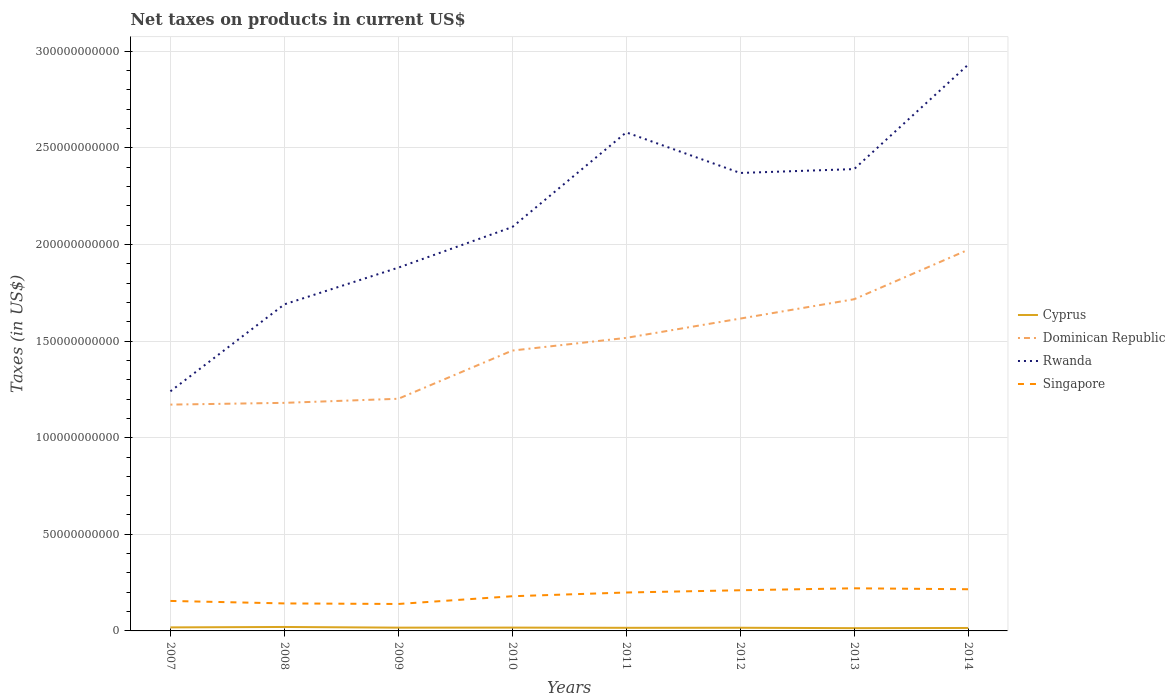Is the number of lines equal to the number of legend labels?
Keep it short and to the point. Yes. Across all years, what is the maximum net taxes on products in Singapore?
Your answer should be compact. 1.39e+1. What is the total net taxes on products in Dominican Republic in the graph?
Your response must be concise. -6.57e+09. What is the difference between the highest and the second highest net taxes on products in Cyprus?
Offer a very short reply. 6.08e+08. What is the difference between the highest and the lowest net taxes on products in Rwanda?
Provide a short and direct response. 4. How many years are there in the graph?
Provide a short and direct response. 8. Are the values on the major ticks of Y-axis written in scientific E-notation?
Offer a terse response. No. Does the graph contain grids?
Make the answer very short. Yes. How many legend labels are there?
Your answer should be compact. 4. How are the legend labels stacked?
Ensure brevity in your answer.  Vertical. What is the title of the graph?
Your response must be concise. Net taxes on products in current US$. Does "Micronesia" appear as one of the legend labels in the graph?
Provide a short and direct response. No. What is the label or title of the Y-axis?
Make the answer very short. Taxes (in US$). What is the Taxes (in US$) in Cyprus in 2007?
Your answer should be very brief. 1.83e+09. What is the Taxes (in US$) in Dominican Republic in 2007?
Provide a short and direct response. 1.17e+11. What is the Taxes (in US$) in Rwanda in 2007?
Keep it short and to the point. 1.24e+11. What is the Taxes (in US$) in Singapore in 2007?
Your answer should be compact. 1.55e+1. What is the Taxes (in US$) of Cyprus in 2008?
Your response must be concise. 2.04e+09. What is the Taxes (in US$) in Dominican Republic in 2008?
Your answer should be very brief. 1.18e+11. What is the Taxes (in US$) of Rwanda in 2008?
Offer a terse response. 1.69e+11. What is the Taxes (in US$) of Singapore in 2008?
Give a very brief answer. 1.42e+1. What is the Taxes (in US$) of Cyprus in 2009?
Offer a very short reply. 1.70e+09. What is the Taxes (in US$) of Dominican Republic in 2009?
Your answer should be compact. 1.20e+11. What is the Taxes (in US$) in Rwanda in 2009?
Provide a succinct answer. 1.88e+11. What is the Taxes (in US$) in Singapore in 2009?
Your answer should be compact. 1.39e+1. What is the Taxes (in US$) in Cyprus in 2010?
Give a very brief answer. 1.72e+09. What is the Taxes (in US$) of Dominican Republic in 2010?
Offer a very short reply. 1.45e+11. What is the Taxes (in US$) of Rwanda in 2010?
Your response must be concise. 2.09e+11. What is the Taxes (in US$) in Singapore in 2010?
Offer a terse response. 1.80e+1. What is the Taxes (in US$) in Cyprus in 2011?
Your answer should be compact. 1.61e+09. What is the Taxes (in US$) in Dominican Republic in 2011?
Your response must be concise. 1.52e+11. What is the Taxes (in US$) of Rwanda in 2011?
Make the answer very short. 2.58e+11. What is the Taxes (in US$) in Singapore in 2011?
Your response must be concise. 1.99e+1. What is the Taxes (in US$) in Cyprus in 2012?
Provide a short and direct response. 1.64e+09. What is the Taxes (in US$) in Dominican Republic in 2012?
Provide a short and direct response. 1.62e+11. What is the Taxes (in US$) in Rwanda in 2012?
Your response must be concise. 2.37e+11. What is the Taxes (in US$) of Singapore in 2012?
Ensure brevity in your answer.  2.10e+1. What is the Taxes (in US$) of Cyprus in 2013?
Provide a short and direct response. 1.43e+09. What is the Taxes (in US$) in Dominican Republic in 2013?
Keep it short and to the point. 1.72e+11. What is the Taxes (in US$) in Rwanda in 2013?
Offer a very short reply. 2.39e+11. What is the Taxes (in US$) in Singapore in 2013?
Your answer should be compact. 2.21e+1. What is the Taxes (in US$) in Cyprus in 2014?
Provide a succinct answer. 1.53e+09. What is the Taxes (in US$) in Dominican Republic in 2014?
Ensure brevity in your answer.  1.97e+11. What is the Taxes (in US$) in Rwanda in 2014?
Provide a short and direct response. 2.93e+11. What is the Taxes (in US$) of Singapore in 2014?
Offer a very short reply. 2.16e+1. Across all years, what is the maximum Taxes (in US$) in Cyprus?
Provide a succinct answer. 2.04e+09. Across all years, what is the maximum Taxes (in US$) in Dominican Republic?
Provide a succinct answer. 1.97e+11. Across all years, what is the maximum Taxes (in US$) of Rwanda?
Provide a succinct answer. 2.93e+11. Across all years, what is the maximum Taxes (in US$) in Singapore?
Your answer should be very brief. 2.21e+1. Across all years, what is the minimum Taxes (in US$) in Cyprus?
Provide a short and direct response. 1.43e+09. Across all years, what is the minimum Taxes (in US$) in Dominican Republic?
Provide a succinct answer. 1.17e+11. Across all years, what is the minimum Taxes (in US$) of Rwanda?
Your answer should be compact. 1.24e+11. Across all years, what is the minimum Taxes (in US$) of Singapore?
Offer a very short reply. 1.39e+1. What is the total Taxes (in US$) of Cyprus in the graph?
Provide a succinct answer. 1.35e+1. What is the total Taxes (in US$) of Dominican Republic in the graph?
Provide a short and direct response. 1.18e+12. What is the total Taxes (in US$) of Rwanda in the graph?
Offer a terse response. 1.72e+12. What is the total Taxes (in US$) in Singapore in the graph?
Give a very brief answer. 1.46e+11. What is the difference between the Taxes (in US$) in Cyprus in 2007 and that in 2008?
Provide a short and direct response. -2.14e+08. What is the difference between the Taxes (in US$) of Dominican Republic in 2007 and that in 2008?
Offer a very short reply. -9.12e+08. What is the difference between the Taxes (in US$) of Rwanda in 2007 and that in 2008?
Make the answer very short. -4.50e+1. What is the difference between the Taxes (in US$) in Singapore in 2007 and that in 2008?
Your answer should be very brief. 1.29e+09. What is the difference between the Taxes (in US$) in Cyprus in 2007 and that in 2009?
Make the answer very short. 1.28e+08. What is the difference between the Taxes (in US$) of Dominican Republic in 2007 and that in 2009?
Offer a very short reply. -3.02e+09. What is the difference between the Taxes (in US$) in Rwanda in 2007 and that in 2009?
Provide a succinct answer. -6.40e+1. What is the difference between the Taxes (in US$) in Singapore in 2007 and that in 2009?
Your response must be concise. 1.58e+09. What is the difference between the Taxes (in US$) of Cyprus in 2007 and that in 2010?
Keep it short and to the point. 1.10e+08. What is the difference between the Taxes (in US$) in Dominican Republic in 2007 and that in 2010?
Your response must be concise. -2.80e+1. What is the difference between the Taxes (in US$) of Rwanda in 2007 and that in 2010?
Your answer should be very brief. -8.50e+1. What is the difference between the Taxes (in US$) in Singapore in 2007 and that in 2010?
Make the answer very short. -2.43e+09. What is the difference between the Taxes (in US$) of Cyprus in 2007 and that in 2011?
Ensure brevity in your answer.  2.18e+08. What is the difference between the Taxes (in US$) of Dominican Republic in 2007 and that in 2011?
Give a very brief answer. -3.45e+1. What is the difference between the Taxes (in US$) of Rwanda in 2007 and that in 2011?
Provide a short and direct response. -1.34e+11. What is the difference between the Taxes (in US$) in Singapore in 2007 and that in 2011?
Offer a terse response. -4.36e+09. What is the difference between the Taxes (in US$) in Cyprus in 2007 and that in 2012?
Provide a short and direct response. 1.90e+08. What is the difference between the Taxes (in US$) in Dominican Republic in 2007 and that in 2012?
Offer a terse response. -4.45e+1. What is the difference between the Taxes (in US$) in Rwanda in 2007 and that in 2012?
Ensure brevity in your answer.  -1.13e+11. What is the difference between the Taxes (in US$) of Singapore in 2007 and that in 2012?
Provide a succinct answer. -5.53e+09. What is the difference between the Taxes (in US$) in Cyprus in 2007 and that in 2013?
Give a very brief answer. 3.95e+08. What is the difference between the Taxes (in US$) of Dominican Republic in 2007 and that in 2013?
Give a very brief answer. -5.45e+1. What is the difference between the Taxes (in US$) in Rwanda in 2007 and that in 2013?
Your answer should be compact. -1.15e+11. What is the difference between the Taxes (in US$) in Singapore in 2007 and that in 2013?
Offer a very short reply. -6.54e+09. What is the difference between the Taxes (in US$) in Cyprus in 2007 and that in 2014?
Make the answer very short. 3.02e+08. What is the difference between the Taxes (in US$) in Dominican Republic in 2007 and that in 2014?
Make the answer very short. -8.01e+1. What is the difference between the Taxes (in US$) of Rwanda in 2007 and that in 2014?
Your answer should be very brief. -1.69e+11. What is the difference between the Taxes (in US$) in Singapore in 2007 and that in 2014?
Your answer should be compact. -6.05e+09. What is the difference between the Taxes (in US$) of Cyprus in 2008 and that in 2009?
Your response must be concise. 3.42e+08. What is the difference between the Taxes (in US$) of Dominican Republic in 2008 and that in 2009?
Give a very brief answer. -2.11e+09. What is the difference between the Taxes (in US$) in Rwanda in 2008 and that in 2009?
Keep it short and to the point. -1.90e+1. What is the difference between the Taxes (in US$) of Singapore in 2008 and that in 2009?
Your response must be concise. 2.89e+08. What is the difference between the Taxes (in US$) in Cyprus in 2008 and that in 2010?
Provide a short and direct response. 3.24e+08. What is the difference between the Taxes (in US$) of Dominican Republic in 2008 and that in 2010?
Your answer should be compact. -2.71e+1. What is the difference between the Taxes (in US$) in Rwanda in 2008 and that in 2010?
Provide a succinct answer. -4.00e+1. What is the difference between the Taxes (in US$) in Singapore in 2008 and that in 2010?
Offer a very short reply. -3.72e+09. What is the difference between the Taxes (in US$) in Cyprus in 2008 and that in 2011?
Make the answer very short. 4.32e+08. What is the difference between the Taxes (in US$) of Dominican Republic in 2008 and that in 2011?
Provide a short and direct response. -3.36e+1. What is the difference between the Taxes (in US$) of Rwanda in 2008 and that in 2011?
Ensure brevity in your answer.  -8.90e+1. What is the difference between the Taxes (in US$) in Singapore in 2008 and that in 2011?
Give a very brief answer. -5.65e+09. What is the difference between the Taxes (in US$) in Cyprus in 2008 and that in 2012?
Keep it short and to the point. 4.03e+08. What is the difference between the Taxes (in US$) in Dominican Republic in 2008 and that in 2012?
Your response must be concise. -4.36e+1. What is the difference between the Taxes (in US$) of Rwanda in 2008 and that in 2012?
Provide a succinct answer. -6.80e+1. What is the difference between the Taxes (in US$) in Singapore in 2008 and that in 2012?
Keep it short and to the point. -6.81e+09. What is the difference between the Taxes (in US$) of Cyprus in 2008 and that in 2013?
Give a very brief answer. 6.08e+08. What is the difference between the Taxes (in US$) of Dominican Republic in 2008 and that in 2013?
Make the answer very short. -5.36e+1. What is the difference between the Taxes (in US$) in Rwanda in 2008 and that in 2013?
Offer a terse response. -7.00e+1. What is the difference between the Taxes (in US$) in Singapore in 2008 and that in 2013?
Your response must be concise. -7.83e+09. What is the difference between the Taxes (in US$) in Cyprus in 2008 and that in 2014?
Your answer should be compact. 5.16e+08. What is the difference between the Taxes (in US$) in Dominican Republic in 2008 and that in 2014?
Your answer should be compact. -7.92e+1. What is the difference between the Taxes (in US$) in Rwanda in 2008 and that in 2014?
Make the answer very short. -1.24e+11. What is the difference between the Taxes (in US$) in Singapore in 2008 and that in 2014?
Your answer should be compact. -7.34e+09. What is the difference between the Taxes (in US$) of Cyprus in 2009 and that in 2010?
Your answer should be compact. -1.81e+07. What is the difference between the Taxes (in US$) of Dominican Republic in 2009 and that in 2010?
Your response must be concise. -2.49e+1. What is the difference between the Taxes (in US$) of Rwanda in 2009 and that in 2010?
Make the answer very short. -2.10e+1. What is the difference between the Taxes (in US$) in Singapore in 2009 and that in 2010?
Offer a terse response. -4.01e+09. What is the difference between the Taxes (in US$) in Cyprus in 2009 and that in 2011?
Provide a succinct answer. 9.02e+07. What is the difference between the Taxes (in US$) of Dominican Republic in 2009 and that in 2011?
Offer a terse response. -3.15e+1. What is the difference between the Taxes (in US$) of Rwanda in 2009 and that in 2011?
Provide a short and direct response. -7.00e+1. What is the difference between the Taxes (in US$) in Singapore in 2009 and that in 2011?
Give a very brief answer. -5.94e+09. What is the difference between the Taxes (in US$) of Cyprus in 2009 and that in 2012?
Provide a short and direct response. 6.17e+07. What is the difference between the Taxes (in US$) of Dominican Republic in 2009 and that in 2012?
Offer a very short reply. -4.15e+1. What is the difference between the Taxes (in US$) in Rwanda in 2009 and that in 2012?
Your response must be concise. -4.90e+1. What is the difference between the Taxes (in US$) in Singapore in 2009 and that in 2012?
Ensure brevity in your answer.  -7.10e+09. What is the difference between the Taxes (in US$) in Cyprus in 2009 and that in 2013?
Ensure brevity in your answer.  2.66e+08. What is the difference between the Taxes (in US$) of Dominican Republic in 2009 and that in 2013?
Ensure brevity in your answer.  -5.15e+1. What is the difference between the Taxes (in US$) in Rwanda in 2009 and that in 2013?
Offer a very short reply. -5.10e+1. What is the difference between the Taxes (in US$) of Singapore in 2009 and that in 2013?
Offer a very short reply. -8.12e+09. What is the difference between the Taxes (in US$) in Cyprus in 2009 and that in 2014?
Your response must be concise. 1.74e+08. What is the difference between the Taxes (in US$) in Dominican Republic in 2009 and that in 2014?
Make the answer very short. -7.71e+1. What is the difference between the Taxes (in US$) in Rwanda in 2009 and that in 2014?
Give a very brief answer. -1.05e+11. What is the difference between the Taxes (in US$) of Singapore in 2009 and that in 2014?
Your response must be concise. -7.63e+09. What is the difference between the Taxes (in US$) of Cyprus in 2010 and that in 2011?
Ensure brevity in your answer.  1.08e+08. What is the difference between the Taxes (in US$) in Dominican Republic in 2010 and that in 2011?
Your response must be concise. -6.57e+09. What is the difference between the Taxes (in US$) of Rwanda in 2010 and that in 2011?
Offer a very short reply. -4.90e+1. What is the difference between the Taxes (in US$) of Singapore in 2010 and that in 2011?
Offer a terse response. -1.93e+09. What is the difference between the Taxes (in US$) of Cyprus in 2010 and that in 2012?
Ensure brevity in your answer.  7.99e+07. What is the difference between the Taxes (in US$) of Dominican Republic in 2010 and that in 2012?
Provide a short and direct response. -1.65e+1. What is the difference between the Taxes (in US$) in Rwanda in 2010 and that in 2012?
Ensure brevity in your answer.  -2.80e+1. What is the difference between the Taxes (in US$) of Singapore in 2010 and that in 2012?
Offer a very short reply. -3.10e+09. What is the difference between the Taxes (in US$) of Cyprus in 2010 and that in 2013?
Your response must be concise. 2.84e+08. What is the difference between the Taxes (in US$) of Dominican Republic in 2010 and that in 2013?
Offer a very short reply. -2.66e+1. What is the difference between the Taxes (in US$) of Rwanda in 2010 and that in 2013?
Your answer should be compact. -3.00e+1. What is the difference between the Taxes (in US$) of Singapore in 2010 and that in 2013?
Your response must be concise. -4.11e+09. What is the difference between the Taxes (in US$) in Cyprus in 2010 and that in 2014?
Offer a terse response. 1.92e+08. What is the difference between the Taxes (in US$) of Dominican Republic in 2010 and that in 2014?
Keep it short and to the point. -5.21e+1. What is the difference between the Taxes (in US$) of Rwanda in 2010 and that in 2014?
Ensure brevity in your answer.  -8.40e+1. What is the difference between the Taxes (in US$) in Singapore in 2010 and that in 2014?
Your answer should be very brief. -3.62e+09. What is the difference between the Taxes (in US$) of Cyprus in 2011 and that in 2012?
Your answer should be compact. -2.85e+07. What is the difference between the Taxes (in US$) in Dominican Republic in 2011 and that in 2012?
Offer a very short reply. -9.98e+09. What is the difference between the Taxes (in US$) in Rwanda in 2011 and that in 2012?
Keep it short and to the point. 2.10e+1. What is the difference between the Taxes (in US$) of Singapore in 2011 and that in 2012?
Offer a very short reply. -1.17e+09. What is the difference between the Taxes (in US$) of Cyprus in 2011 and that in 2013?
Make the answer very short. 1.76e+08. What is the difference between the Taxes (in US$) of Dominican Republic in 2011 and that in 2013?
Provide a short and direct response. -2.00e+1. What is the difference between the Taxes (in US$) in Rwanda in 2011 and that in 2013?
Provide a short and direct response. 1.90e+1. What is the difference between the Taxes (in US$) of Singapore in 2011 and that in 2013?
Your response must be concise. -2.18e+09. What is the difference between the Taxes (in US$) of Cyprus in 2011 and that in 2014?
Your answer should be compact. 8.39e+07. What is the difference between the Taxes (in US$) in Dominican Republic in 2011 and that in 2014?
Keep it short and to the point. -4.56e+1. What is the difference between the Taxes (in US$) in Rwanda in 2011 and that in 2014?
Offer a very short reply. -3.50e+1. What is the difference between the Taxes (in US$) of Singapore in 2011 and that in 2014?
Provide a short and direct response. -1.69e+09. What is the difference between the Taxes (in US$) of Cyprus in 2012 and that in 2013?
Your answer should be compact. 2.05e+08. What is the difference between the Taxes (in US$) of Dominican Republic in 2012 and that in 2013?
Provide a succinct answer. -1.00e+1. What is the difference between the Taxes (in US$) of Rwanda in 2012 and that in 2013?
Provide a succinct answer. -2.00e+09. What is the difference between the Taxes (in US$) of Singapore in 2012 and that in 2013?
Offer a very short reply. -1.01e+09. What is the difference between the Taxes (in US$) in Cyprus in 2012 and that in 2014?
Provide a short and direct response. 1.12e+08. What is the difference between the Taxes (in US$) in Dominican Republic in 2012 and that in 2014?
Give a very brief answer. -3.56e+1. What is the difference between the Taxes (in US$) in Rwanda in 2012 and that in 2014?
Your response must be concise. -5.60e+1. What is the difference between the Taxes (in US$) of Singapore in 2012 and that in 2014?
Your answer should be very brief. -5.23e+08. What is the difference between the Taxes (in US$) in Cyprus in 2013 and that in 2014?
Offer a very short reply. -9.22e+07. What is the difference between the Taxes (in US$) of Dominican Republic in 2013 and that in 2014?
Your response must be concise. -2.56e+1. What is the difference between the Taxes (in US$) of Rwanda in 2013 and that in 2014?
Provide a short and direct response. -5.40e+1. What is the difference between the Taxes (in US$) of Singapore in 2013 and that in 2014?
Offer a very short reply. 4.90e+08. What is the difference between the Taxes (in US$) in Cyprus in 2007 and the Taxes (in US$) in Dominican Republic in 2008?
Your response must be concise. -1.16e+11. What is the difference between the Taxes (in US$) in Cyprus in 2007 and the Taxes (in US$) in Rwanda in 2008?
Provide a short and direct response. -1.67e+11. What is the difference between the Taxes (in US$) of Cyprus in 2007 and the Taxes (in US$) of Singapore in 2008?
Your answer should be very brief. -1.24e+1. What is the difference between the Taxes (in US$) of Dominican Republic in 2007 and the Taxes (in US$) of Rwanda in 2008?
Your answer should be compact. -5.19e+1. What is the difference between the Taxes (in US$) in Dominican Republic in 2007 and the Taxes (in US$) in Singapore in 2008?
Your response must be concise. 1.03e+11. What is the difference between the Taxes (in US$) in Rwanda in 2007 and the Taxes (in US$) in Singapore in 2008?
Ensure brevity in your answer.  1.10e+11. What is the difference between the Taxes (in US$) of Cyprus in 2007 and the Taxes (in US$) of Dominican Republic in 2009?
Provide a short and direct response. -1.18e+11. What is the difference between the Taxes (in US$) in Cyprus in 2007 and the Taxes (in US$) in Rwanda in 2009?
Make the answer very short. -1.86e+11. What is the difference between the Taxes (in US$) in Cyprus in 2007 and the Taxes (in US$) in Singapore in 2009?
Keep it short and to the point. -1.21e+1. What is the difference between the Taxes (in US$) in Dominican Republic in 2007 and the Taxes (in US$) in Rwanda in 2009?
Your response must be concise. -7.09e+1. What is the difference between the Taxes (in US$) in Dominican Republic in 2007 and the Taxes (in US$) in Singapore in 2009?
Your response must be concise. 1.03e+11. What is the difference between the Taxes (in US$) of Rwanda in 2007 and the Taxes (in US$) of Singapore in 2009?
Your answer should be compact. 1.10e+11. What is the difference between the Taxes (in US$) in Cyprus in 2007 and the Taxes (in US$) in Dominican Republic in 2010?
Offer a terse response. -1.43e+11. What is the difference between the Taxes (in US$) in Cyprus in 2007 and the Taxes (in US$) in Rwanda in 2010?
Make the answer very short. -2.07e+11. What is the difference between the Taxes (in US$) in Cyprus in 2007 and the Taxes (in US$) in Singapore in 2010?
Offer a terse response. -1.61e+1. What is the difference between the Taxes (in US$) in Dominican Republic in 2007 and the Taxes (in US$) in Rwanda in 2010?
Offer a terse response. -9.19e+1. What is the difference between the Taxes (in US$) of Dominican Republic in 2007 and the Taxes (in US$) of Singapore in 2010?
Your response must be concise. 9.92e+1. What is the difference between the Taxes (in US$) in Rwanda in 2007 and the Taxes (in US$) in Singapore in 2010?
Provide a short and direct response. 1.06e+11. What is the difference between the Taxes (in US$) of Cyprus in 2007 and the Taxes (in US$) of Dominican Republic in 2011?
Keep it short and to the point. -1.50e+11. What is the difference between the Taxes (in US$) in Cyprus in 2007 and the Taxes (in US$) in Rwanda in 2011?
Your answer should be very brief. -2.56e+11. What is the difference between the Taxes (in US$) in Cyprus in 2007 and the Taxes (in US$) in Singapore in 2011?
Give a very brief answer. -1.81e+1. What is the difference between the Taxes (in US$) of Dominican Republic in 2007 and the Taxes (in US$) of Rwanda in 2011?
Provide a short and direct response. -1.41e+11. What is the difference between the Taxes (in US$) in Dominican Republic in 2007 and the Taxes (in US$) in Singapore in 2011?
Make the answer very short. 9.72e+1. What is the difference between the Taxes (in US$) in Rwanda in 2007 and the Taxes (in US$) in Singapore in 2011?
Make the answer very short. 1.04e+11. What is the difference between the Taxes (in US$) in Cyprus in 2007 and the Taxes (in US$) in Dominican Republic in 2012?
Keep it short and to the point. -1.60e+11. What is the difference between the Taxes (in US$) of Cyprus in 2007 and the Taxes (in US$) of Rwanda in 2012?
Your answer should be compact. -2.35e+11. What is the difference between the Taxes (in US$) in Cyprus in 2007 and the Taxes (in US$) in Singapore in 2012?
Provide a short and direct response. -1.92e+1. What is the difference between the Taxes (in US$) of Dominican Republic in 2007 and the Taxes (in US$) of Rwanda in 2012?
Make the answer very short. -1.20e+11. What is the difference between the Taxes (in US$) in Dominican Republic in 2007 and the Taxes (in US$) in Singapore in 2012?
Give a very brief answer. 9.61e+1. What is the difference between the Taxes (in US$) of Rwanda in 2007 and the Taxes (in US$) of Singapore in 2012?
Your response must be concise. 1.03e+11. What is the difference between the Taxes (in US$) in Cyprus in 2007 and the Taxes (in US$) in Dominican Republic in 2013?
Keep it short and to the point. -1.70e+11. What is the difference between the Taxes (in US$) of Cyprus in 2007 and the Taxes (in US$) of Rwanda in 2013?
Offer a very short reply. -2.37e+11. What is the difference between the Taxes (in US$) in Cyprus in 2007 and the Taxes (in US$) in Singapore in 2013?
Keep it short and to the point. -2.02e+1. What is the difference between the Taxes (in US$) in Dominican Republic in 2007 and the Taxes (in US$) in Rwanda in 2013?
Provide a succinct answer. -1.22e+11. What is the difference between the Taxes (in US$) of Dominican Republic in 2007 and the Taxes (in US$) of Singapore in 2013?
Provide a short and direct response. 9.51e+1. What is the difference between the Taxes (in US$) in Rwanda in 2007 and the Taxes (in US$) in Singapore in 2013?
Your response must be concise. 1.02e+11. What is the difference between the Taxes (in US$) of Cyprus in 2007 and the Taxes (in US$) of Dominican Republic in 2014?
Give a very brief answer. -1.95e+11. What is the difference between the Taxes (in US$) of Cyprus in 2007 and the Taxes (in US$) of Rwanda in 2014?
Your response must be concise. -2.91e+11. What is the difference between the Taxes (in US$) of Cyprus in 2007 and the Taxes (in US$) of Singapore in 2014?
Keep it short and to the point. -1.97e+1. What is the difference between the Taxes (in US$) in Dominican Republic in 2007 and the Taxes (in US$) in Rwanda in 2014?
Offer a very short reply. -1.76e+11. What is the difference between the Taxes (in US$) in Dominican Republic in 2007 and the Taxes (in US$) in Singapore in 2014?
Your answer should be compact. 9.55e+1. What is the difference between the Taxes (in US$) in Rwanda in 2007 and the Taxes (in US$) in Singapore in 2014?
Give a very brief answer. 1.02e+11. What is the difference between the Taxes (in US$) in Cyprus in 2008 and the Taxes (in US$) in Dominican Republic in 2009?
Your answer should be very brief. -1.18e+11. What is the difference between the Taxes (in US$) of Cyprus in 2008 and the Taxes (in US$) of Rwanda in 2009?
Ensure brevity in your answer.  -1.86e+11. What is the difference between the Taxes (in US$) in Cyprus in 2008 and the Taxes (in US$) in Singapore in 2009?
Give a very brief answer. -1.19e+1. What is the difference between the Taxes (in US$) of Dominican Republic in 2008 and the Taxes (in US$) of Rwanda in 2009?
Give a very brief answer. -7.00e+1. What is the difference between the Taxes (in US$) in Dominican Republic in 2008 and the Taxes (in US$) in Singapore in 2009?
Your response must be concise. 1.04e+11. What is the difference between the Taxes (in US$) of Rwanda in 2008 and the Taxes (in US$) of Singapore in 2009?
Offer a terse response. 1.55e+11. What is the difference between the Taxes (in US$) of Cyprus in 2008 and the Taxes (in US$) of Dominican Republic in 2010?
Provide a succinct answer. -1.43e+11. What is the difference between the Taxes (in US$) in Cyprus in 2008 and the Taxes (in US$) in Rwanda in 2010?
Make the answer very short. -2.07e+11. What is the difference between the Taxes (in US$) of Cyprus in 2008 and the Taxes (in US$) of Singapore in 2010?
Offer a terse response. -1.59e+1. What is the difference between the Taxes (in US$) in Dominican Republic in 2008 and the Taxes (in US$) in Rwanda in 2010?
Provide a short and direct response. -9.10e+1. What is the difference between the Taxes (in US$) of Dominican Republic in 2008 and the Taxes (in US$) of Singapore in 2010?
Your answer should be very brief. 1.00e+11. What is the difference between the Taxes (in US$) of Rwanda in 2008 and the Taxes (in US$) of Singapore in 2010?
Your answer should be very brief. 1.51e+11. What is the difference between the Taxes (in US$) in Cyprus in 2008 and the Taxes (in US$) in Dominican Republic in 2011?
Ensure brevity in your answer.  -1.50e+11. What is the difference between the Taxes (in US$) in Cyprus in 2008 and the Taxes (in US$) in Rwanda in 2011?
Your answer should be compact. -2.56e+11. What is the difference between the Taxes (in US$) in Cyprus in 2008 and the Taxes (in US$) in Singapore in 2011?
Make the answer very short. -1.78e+1. What is the difference between the Taxes (in US$) of Dominican Republic in 2008 and the Taxes (in US$) of Rwanda in 2011?
Ensure brevity in your answer.  -1.40e+11. What is the difference between the Taxes (in US$) in Dominican Republic in 2008 and the Taxes (in US$) in Singapore in 2011?
Offer a very short reply. 9.81e+1. What is the difference between the Taxes (in US$) of Rwanda in 2008 and the Taxes (in US$) of Singapore in 2011?
Provide a short and direct response. 1.49e+11. What is the difference between the Taxes (in US$) in Cyprus in 2008 and the Taxes (in US$) in Dominican Republic in 2012?
Provide a short and direct response. -1.60e+11. What is the difference between the Taxes (in US$) in Cyprus in 2008 and the Taxes (in US$) in Rwanda in 2012?
Your response must be concise. -2.35e+11. What is the difference between the Taxes (in US$) of Cyprus in 2008 and the Taxes (in US$) of Singapore in 2012?
Offer a very short reply. -1.90e+1. What is the difference between the Taxes (in US$) in Dominican Republic in 2008 and the Taxes (in US$) in Rwanda in 2012?
Your response must be concise. -1.19e+11. What is the difference between the Taxes (in US$) in Dominican Republic in 2008 and the Taxes (in US$) in Singapore in 2012?
Provide a short and direct response. 9.70e+1. What is the difference between the Taxes (in US$) of Rwanda in 2008 and the Taxes (in US$) of Singapore in 2012?
Your answer should be compact. 1.48e+11. What is the difference between the Taxes (in US$) of Cyprus in 2008 and the Taxes (in US$) of Dominican Republic in 2013?
Your answer should be compact. -1.70e+11. What is the difference between the Taxes (in US$) of Cyprus in 2008 and the Taxes (in US$) of Rwanda in 2013?
Give a very brief answer. -2.37e+11. What is the difference between the Taxes (in US$) in Cyprus in 2008 and the Taxes (in US$) in Singapore in 2013?
Make the answer very short. -2.00e+1. What is the difference between the Taxes (in US$) in Dominican Republic in 2008 and the Taxes (in US$) in Rwanda in 2013?
Offer a very short reply. -1.21e+11. What is the difference between the Taxes (in US$) in Dominican Republic in 2008 and the Taxes (in US$) in Singapore in 2013?
Ensure brevity in your answer.  9.60e+1. What is the difference between the Taxes (in US$) in Rwanda in 2008 and the Taxes (in US$) in Singapore in 2013?
Offer a very short reply. 1.47e+11. What is the difference between the Taxes (in US$) in Cyprus in 2008 and the Taxes (in US$) in Dominican Republic in 2014?
Your answer should be very brief. -1.95e+11. What is the difference between the Taxes (in US$) in Cyprus in 2008 and the Taxes (in US$) in Rwanda in 2014?
Provide a succinct answer. -2.91e+11. What is the difference between the Taxes (in US$) of Cyprus in 2008 and the Taxes (in US$) of Singapore in 2014?
Make the answer very short. -1.95e+1. What is the difference between the Taxes (in US$) in Dominican Republic in 2008 and the Taxes (in US$) in Rwanda in 2014?
Offer a very short reply. -1.75e+11. What is the difference between the Taxes (in US$) in Dominican Republic in 2008 and the Taxes (in US$) in Singapore in 2014?
Provide a short and direct response. 9.65e+1. What is the difference between the Taxes (in US$) in Rwanda in 2008 and the Taxes (in US$) in Singapore in 2014?
Provide a succinct answer. 1.47e+11. What is the difference between the Taxes (in US$) in Cyprus in 2009 and the Taxes (in US$) in Dominican Republic in 2010?
Offer a terse response. -1.43e+11. What is the difference between the Taxes (in US$) of Cyprus in 2009 and the Taxes (in US$) of Rwanda in 2010?
Keep it short and to the point. -2.07e+11. What is the difference between the Taxes (in US$) of Cyprus in 2009 and the Taxes (in US$) of Singapore in 2010?
Give a very brief answer. -1.62e+1. What is the difference between the Taxes (in US$) of Dominican Republic in 2009 and the Taxes (in US$) of Rwanda in 2010?
Provide a short and direct response. -8.89e+1. What is the difference between the Taxes (in US$) of Dominican Republic in 2009 and the Taxes (in US$) of Singapore in 2010?
Make the answer very short. 1.02e+11. What is the difference between the Taxes (in US$) of Rwanda in 2009 and the Taxes (in US$) of Singapore in 2010?
Your answer should be very brief. 1.70e+11. What is the difference between the Taxes (in US$) of Cyprus in 2009 and the Taxes (in US$) of Dominican Republic in 2011?
Provide a succinct answer. -1.50e+11. What is the difference between the Taxes (in US$) of Cyprus in 2009 and the Taxes (in US$) of Rwanda in 2011?
Provide a succinct answer. -2.56e+11. What is the difference between the Taxes (in US$) in Cyprus in 2009 and the Taxes (in US$) in Singapore in 2011?
Your answer should be compact. -1.82e+1. What is the difference between the Taxes (in US$) of Dominican Republic in 2009 and the Taxes (in US$) of Rwanda in 2011?
Your answer should be compact. -1.38e+11. What is the difference between the Taxes (in US$) of Dominican Republic in 2009 and the Taxes (in US$) of Singapore in 2011?
Provide a succinct answer. 1.00e+11. What is the difference between the Taxes (in US$) in Rwanda in 2009 and the Taxes (in US$) in Singapore in 2011?
Offer a terse response. 1.68e+11. What is the difference between the Taxes (in US$) in Cyprus in 2009 and the Taxes (in US$) in Dominican Republic in 2012?
Your response must be concise. -1.60e+11. What is the difference between the Taxes (in US$) in Cyprus in 2009 and the Taxes (in US$) in Rwanda in 2012?
Keep it short and to the point. -2.35e+11. What is the difference between the Taxes (in US$) of Cyprus in 2009 and the Taxes (in US$) of Singapore in 2012?
Offer a very short reply. -1.93e+1. What is the difference between the Taxes (in US$) in Dominican Republic in 2009 and the Taxes (in US$) in Rwanda in 2012?
Your answer should be very brief. -1.17e+11. What is the difference between the Taxes (in US$) of Dominican Republic in 2009 and the Taxes (in US$) of Singapore in 2012?
Keep it short and to the point. 9.91e+1. What is the difference between the Taxes (in US$) in Rwanda in 2009 and the Taxes (in US$) in Singapore in 2012?
Your response must be concise. 1.67e+11. What is the difference between the Taxes (in US$) of Cyprus in 2009 and the Taxes (in US$) of Dominican Republic in 2013?
Provide a short and direct response. -1.70e+11. What is the difference between the Taxes (in US$) in Cyprus in 2009 and the Taxes (in US$) in Rwanda in 2013?
Your response must be concise. -2.37e+11. What is the difference between the Taxes (in US$) in Cyprus in 2009 and the Taxes (in US$) in Singapore in 2013?
Offer a very short reply. -2.04e+1. What is the difference between the Taxes (in US$) of Dominican Republic in 2009 and the Taxes (in US$) of Rwanda in 2013?
Give a very brief answer. -1.19e+11. What is the difference between the Taxes (in US$) in Dominican Republic in 2009 and the Taxes (in US$) in Singapore in 2013?
Your answer should be compact. 9.81e+1. What is the difference between the Taxes (in US$) of Rwanda in 2009 and the Taxes (in US$) of Singapore in 2013?
Ensure brevity in your answer.  1.66e+11. What is the difference between the Taxes (in US$) of Cyprus in 2009 and the Taxes (in US$) of Dominican Republic in 2014?
Keep it short and to the point. -1.96e+11. What is the difference between the Taxes (in US$) of Cyprus in 2009 and the Taxes (in US$) of Rwanda in 2014?
Provide a succinct answer. -2.91e+11. What is the difference between the Taxes (in US$) of Cyprus in 2009 and the Taxes (in US$) of Singapore in 2014?
Your answer should be compact. -1.99e+1. What is the difference between the Taxes (in US$) in Dominican Republic in 2009 and the Taxes (in US$) in Rwanda in 2014?
Your response must be concise. -1.73e+11. What is the difference between the Taxes (in US$) of Dominican Republic in 2009 and the Taxes (in US$) of Singapore in 2014?
Offer a terse response. 9.86e+1. What is the difference between the Taxes (in US$) in Rwanda in 2009 and the Taxes (in US$) in Singapore in 2014?
Provide a short and direct response. 1.66e+11. What is the difference between the Taxes (in US$) in Cyprus in 2010 and the Taxes (in US$) in Dominican Republic in 2011?
Provide a short and direct response. -1.50e+11. What is the difference between the Taxes (in US$) of Cyprus in 2010 and the Taxes (in US$) of Rwanda in 2011?
Give a very brief answer. -2.56e+11. What is the difference between the Taxes (in US$) in Cyprus in 2010 and the Taxes (in US$) in Singapore in 2011?
Give a very brief answer. -1.82e+1. What is the difference between the Taxes (in US$) of Dominican Republic in 2010 and the Taxes (in US$) of Rwanda in 2011?
Ensure brevity in your answer.  -1.13e+11. What is the difference between the Taxes (in US$) in Dominican Republic in 2010 and the Taxes (in US$) in Singapore in 2011?
Ensure brevity in your answer.  1.25e+11. What is the difference between the Taxes (in US$) of Rwanda in 2010 and the Taxes (in US$) of Singapore in 2011?
Keep it short and to the point. 1.89e+11. What is the difference between the Taxes (in US$) in Cyprus in 2010 and the Taxes (in US$) in Dominican Republic in 2012?
Provide a short and direct response. -1.60e+11. What is the difference between the Taxes (in US$) of Cyprus in 2010 and the Taxes (in US$) of Rwanda in 2012?
Provide a succinct answer. -2.35e+11. What is the difference between the Taxes (in US$) in Cyprus in 2010 and the Taxes (in US$) in Singapore in 2012?
Your answer should be compact. -1.93e+1. What is the difference between the Taxes (in US$) in Dominican Republic in 2010 and the Taxes (in US$) in Rwanda in 2012?
Ensure brevity in your answer.  -9.19e+1. What is the difference between the Taxes (in US$) of Dominican Republic in 2010 and the Taxes (in US$) of Singapore in 2012?
Offer a terse response. 1.24e+11. What is the difference between the Taxes (in US$) in Rwanda in 2010 and the Taxes (in US$) in Singapore in 2012?
Ensure brevity in your answer.  1.88e+11. What is the difference between the Taxes (in US$) of Cyprus in 2010 and the Taxes (in US$) of Dominican Republic in 2013?
Offer a very short reply. -1.70e+11. What is the difference between the Taxes (in US$) in Cyprus in 2010 and the Taxes (in US$) in Rwanda in 2013?
Ensure brevity in your answer.  -2.37e+11. What is the difference between the Taxes (in US$) of Cyprus in 2010 and the Taxes (in US$) of Singapore in 2013?
Offer a very short reply. -2.03e+1. What is the difference between the Taxes (in US$) in Dominican Republic in 2010 and the Taxes (in US$) in Rwanda in 2013?
Keep it short and to the point. -9.39e+1. What is the difference between the Taxes (in US$) of Dominican Republic in 2010 and the Taxes (in US$) of Singapore in 2013?
Give a very brief answer. 1.23e+11. What is the difference between the Taxes (in US$) in Rwanda in 2010 and the Taxes (in US$) in Singapore in 2013?
Your response must be concise. 1.87e+11. What is the difference between the Taxes (in US$) in Cyprus in 2010 and the Taxes (in US$) in Dominican Republic in 2014?
Give a very brief answer. -1.96e+11. What is the difference between the Taxes (in US$) of Cyprus in 2010 and the Taxes (in US$) of Rwanda in 2014?
Keep it short and to the point. -2.91e+11. What is the difference between the Taxes (in US$) of Cyprus in 2010 and the Taxes (in US$) of Singapore in 2014?
Your answer should be very brief. -1.98e+1. What is the difference between the Taxes (in US$) of Dominican Republic in 2010 and the Taxes (in US$) of Rwanda in 2014?
Make the answer very short. -1.48e+11. What is the difference between the Taxes (in US$) of Dominican Republic in 2010 and the Taxes (in US$) of Singapore in 2014?
Your answer should be compact. 1.24e+11. What is the difference between the Taxes (in US$) of Rwanda in 2010 and the Taxes (in US$) of Singapore in 2014?
Your answer should be compact. 1.87e+11. What is the difference between the Taxes (in US$) of Cyprus in 2011 and the Taxes (in US$) of Dominican Republic in 2012?
Ensure brevity in your answer.  -1.60e+11. What is the difference between the Taxes (in US$) in Cyprus in 2011 and the Taxes (in US$) in Rwanda in 2012?
Ensure brevity in your answer.  -2.35e+11. What is the difference between the Taxes (in US$) of Cyprus in 2011 and the Taxes (in US$) of Singapore in 2012?
Your answer should be compact. -1.94e+1. What is the difference between the Taxes (in US$) of Dominican Republic in 2011 and the Taxes (in US$) of Rwanda in 2012?
Give a very brief answer. -8.53e+1. What is the difference between the Taxes (in US$) in Dominican Republic in 2011 and the Taxes (in US$) in Singapore in 2012?
Ensure brevity in your answer.  1.31e+11. What is the difference between the Taxes (in US$) in Rwanda in 2011 and the Taxes (in US$) in Singapore in 2012?
Keep it short and to the point. 2.37e+11. What is the difference between the Taxes (in US$) in Cyprus in 2011 and the Taxes (in US$) in Dominican Republic in 2013?
Offer a very short reply. -1.70e+11. What is the difference between the Taxes (in US$) in Cyprus in 2011 and the Taxes (in US$) in Rwanda in 2013?
Provide a short and direct response. -2.37e+11. What is the difference between the Taxes (in US$) in Cyprus in 2011 and the Taxes (in US$) in Singapore in 2013?
Keep it short and to the point. -2.04e+1. What is the difference between the Taxes (in US$) of Dominican Republic in 2011 and the Taxes (in US$) of Rwanda in 2013?
Your response must be concise. -8.73e+1. What is the difference between the Taxes (in US$) in Dominican Republic in 2011 and the Taxes (in US$) in Singapore in 2013?
Offer a very short reply. 1.30e+11. What is the difference between the Taxes (in US$) in Rwanda in 2011 and the Taxes (in US$) in Singapore in 2013?
Offer a very short reply. 2.36e+11. What is the difference between the Taxes (in US$) of Cyprus in 2011 and the Taxes (in US$) of Dominican Republic in 2014?
Make the answer very short. -1.96e+11. What is the difference between the Taxes (in US$) of Cyprus in 2011 and the Taxes (in US$) of Rwanda in 2014?
Ensure brevity in your answer.  -2.91e+11. What is the difference between the Taxes (in US$) of Cyprus in 2011 and the Taxes (in US$) of Singapore in 2014?
Provide a succinct answer. -2.00e+1. What is the difference between the Taxes (in US$) of Dominican Republic in 2011 and the Taxes (in US$) of Rwanda in 2014?
Your answer should be compact. -1.41e+11. What is the difference between the Taxes (in US$) of Dominican Republic in 2011 and the Taxes (in US$) of Singapore in 2014?
Your response must be concise. 1.30e+11. What is the difference between the Taxes (in US$) of Rwanda in 2011 and the Taxes (in US$) of Singapore in 2014?
Provide a short and direct response. 2.36e+11. What is the difference between the Taxes (in US$) in Cyprus in 2012 and the Taxes (in US$) in Dominican Republic in 2013?
Provide a short and direct response. -1.70e+11. What is the difference between the Taxes (in US$) of Cyprus in 2012 and the Taxes (in US$) of Rwanda in 2013?
Offer a terse response. -2.37e+11. What is the difference between the Taxes (in US$) in Cyprus in 2012 and the Taxes (in US$) in Singapore in 2013?
Your answer should be compact. -2.04e+1. What is the difference between the Taxes (in US$) of Dominican Republic in 2012 and the Taxes (in US$) of Rwanda in 2013?
Give a very brief answer. -7.74e+1. What is the difference between the Taxes (in US$) of Dominican Republic in 2012 and the Taxes (in US$) of Singapore in 2013?
Your answer should be very brief. 1.40e+11. What is the difference between the Taxes (in US$) in Rwanda in 2012 and the Taxes (in US$) in Singapore in 2013?
Offer a very short reply. 2.15e+11. What is the difference between the Taxes (in US$) of Cyprus in 2012 and the Taxes (in US$) of Dominican Republic in 2014?
Offer a very short reply. -1.96e+11. What is the difference between the Taxes (in US$) in Cyprus in 2012 and the Taxes (in US$) in Rwanda in 2014?
Offer a very short reply. -2.91e+11. What is the difference between the Taxes (in US$) of Cyprus in 2012 and the Taxes (in US$) of Singapore in 2014?
Offer a very short reply. -1.99e+1. What is the difference between the Taxes (in US$) of Dominican Republic in 2012 and the Taxes (in US$) of Rwanda in 2014?
Your answer should be compact. -1.31e+11. What is the difference between the Taxes (in US$) of Dominican Republic in 2012 and the Taxes (in US$) of Singapore in 2014?
Give a very brief answer. 1.40e+11. What is the difference between the Taxes (in US$) in Rwanda in 2012 and the Taxes (in US$) in Singapore in 2014?
Offer a terse response. 2.15e+11. What is the difference between the Taxes (in US$) in Cyprus in 2013 and the Taxes (in US$) in Dominican Republic in 2014?
Offer a terse response. -1.96e+11. What is the difference between the Taxes (in US$) in Cyprus in 2013 and the Taxes (in US$) in Rwanda in 2014?
Offer a very short reply. -2.92e+11. What is the difference between the Taxes (in US$) of Cyprus in 2013 and the Taxes (in US$) of Singapore in 2014?
Ensure brevity in your answer.  -2.01e+1. What is the difference between the Taxes (in US$) in Dominican Republic in 2013 and the Taxes (in US$) in Rwanda in 2014?
Keep it short and to the point. -1.21e+11. What is the difference between the Taxes (in US$) of Dominican Republic in 2013 and the Taxes (in US$) of Singapore in 2014?
Your answer should be very brief. 1.50e+11. What is the difference between the Taxes (in US$) of Rwanda in 2013 and the Taxes (in US$) of Singapore in 2014?
Make the answer very short. 2.17e+11. What is the average Taxes (in US$) of Cyprus per year?
Your answer should be very brief. 1.69e+09. What is the average Taxes (in US$) of Dominican Republic per year?
Your answer should be compact. 1.48e+11. What is the average Taxes (in US$) in Rwanda per year?
Provide a short and direct response. 2.15e+11. What is the average Taxes (in US$) of Singapore per year?
Your answer should be very brief. 1.83e+1. In the year 2007, what is the difference between the Taxes (in US$) of Cyprus and Taxes (in US$) of Dominican Republic?
Ensure brevity in your answer.  -1.15e+11. In the year 2007, what is the difference between the Taxes (in US$) in Cyprus and Taxes (in US$) in Rwanda?
Give a very brief answer. -1.22e+11. In the year 2007, what is the difference between the Taxes (in US$) in Cyprus and Taxes (in US$) in Singapore?
Your answer should be very brief. -1.37e+1. In the year 2007, what is the difference between the Taxes (in US$) in Dominican Republic and Taxes (in US$) in Rwanda?
Offer a very short reply. -6.88e+09. In the year 2007, what is the difference between the Taxes (in US$) in Dominican Republic and Taxes (in US$) in Singapore?
Keep it short and to the point. 1.02e+11. In the year 2007, what is the difference between the Taxes (in US$) of Rwanda and Taxes (in US$) of Singapore?
Give a very brief answer. 1.08e+11. In the year 2008, what is the difference between the Taxes (in US$) in Cyprus and Taxes (in US$) in Dominican Republic?
Ensure brevity in your answer.  -1.16e+11. In the year 2008, what is the difference between the Taxes (in US$) in Cyprus and Taxes (in US$) in Rwanda?
Give a very brief answer. -1.67e+11. In the year 2008, what is the difference between the Taxes (in US$) of Cyprus and Taxes (in US$) of Singapore?
Make the answer very short. -1.22e+1. In the year 2008, what is the difference between the Taxes (in US$) of Dominican Republic and Taxes (in US$) of Rwanda?
Your response must be concise. -5.10e+1. In the year 2008, what is the difference between the Taxes (in US$) in Dominican Republic and Taxes (in US$) in Singapore?
Offer a terse response. 1.04e+11. In the year 2008, what is the difference between the Taxes (in US$) of Rwanda and Taxes (in US$) of Singapore?
Make the answer very short. 1.55e+11. In the year 2009, what is the difference between the Taxes (in US$) of Cyprus and Taxes (in US$) of Dominican Republic?
Ensure brevity in your answer.  -1.18e+11. In the year 2009, what is the difference between the Taxes (in US$) in Cyprus and Taxes (in US$) in Rwanda?
Make the answer very short. -1.86e+11. In the year 2009, what is the difference between the Taxes (in US$) of Cyprus and Taxes (in US$) of Singapore?
Offer a terse response. -1.22e+1. In the year 2009, what is the difference between the Taxes (in US$) in Dominican Republic and Taxes (in US$) in Rwanda?
Provide a succinct answer. -6.79e+1. In the year 2009, what is the difference between the Taxes (in US$) of Dominican Republic and Taxes (in US$) of Singapore?
Provide a short and direct response. 1.06e+11. In the year 2009, what is the difference between the Taxes (in US$) in Rwanda and Taxes (in US$) in Singapore?
Make the answer very short. 1.74e+11. In the year 2010, what is the difference between the Taxes (in US$) of Cyprus and Taxes (in US$) of Dominican Republic?
Provide a succinct answer. -1.43e+11. In the year 2010, what is the difference between the Taxes (in US$) of Cyprus and Taxes (in US$) of Rwanda?
Provide a succinct answer. -2.07e+11. In the year 2010, what is the difference between the Taxes (in US$) of Cyprus and Taxes (in US$) of Singapore?
Provide a succinct answer. -1.62e+1. In the year 2010, what is the difference between the Taxes (in US$) of Dominican Republic and Taxes (in US$) of Rwanda?
Keep it short and to the point. -6.39e+1. In the year 2010, what is the difference between the Taxes (in US$) in Dominican Republic and Taxes (in US$) in Singapore?
Offer a very short reply. 1.27e+11. In the year 2010, what is the difference between the Taxes (in US$) of Rwanda and Taxes (in US$) of Singapore?
Your response must be concise. 1.91e+11. In the year 2011, what is the difference between the Taxes (in US$) of Cyprus and Taxes (in US$) of Dominican Republic?
Make the answer very short. -1.50e+11. In the year 2011, what is the difference between the Taxes (in US$) in Cyprus and Taxes (in US$) in Rwanda?
Your answer should be very brief. -2.56e+11. In the year 2011, what is the difference between the Taxes (in US$) in Cyprus and Taxes (in US$) in Singapore?
Your response must be concise. -1.83e+1. In the year 2011, what is the difference between the Taxes (in US$) in Dominican Republic and Taxes (in US$) in Rwanda?
Offer a very short reply. -1.06e+11. In the year 2011, what is the difference between the Taxes (in US$) of Dominican Republic and Taxes (in US$) of Singapore?
Keep it short and to the point. 1.32e+11. In the year 2011, what is the difference between the Taxes (in US$) of Rwanda and Taxes (in US$) of Singapore?
Provide a short and direct response. 2.38e+11. In the year 2012, what is the difference between the Taxes (in US$) of Cyprus and Taxes (in US$) of Dominican Republic?
Make the answer very short. -1.60e+11. In the year 2012, what is the difference between the Taxes (in US$) in Cyprus and Taxes (in US$) in Rwanda?
Give a very brief answer. -2.35e+11. In the year 2012, what is the difference between the Taxes (in US$) in Cyprus and Taxes (in US$) in Singapore?
Your response must be concise. -1.94e+1. In the year 2012, what is the difference between the Taxes (in US$) of Dominican Republic and Taxes (in US$) of Rwanda?
Offer a terse response. -7.54e+1. In the year 2012, what is the difference between the Taxes (in US$) of Dominican Republic and Taxes (in US$) of Singapore?
Make the answer very short. 1.41e+11. In the year 2012, what is the difference between the Taxes (in US$) in Rwanda and Taxes (in US$) in Singapore?
Make the answer very short. 2.16e+11. In the year 2013, what is the difference between the Taxes (in US$) of Cyprus and Taxes (in US$) of Dominican Republic?
Provide a short and direct response. -1.70e+11. In the year 2013, what is the difference between the Taxes (in US$) of Cyprus and Taxes (in US$) of Rwanda?
Ensure brevity in your answer.  -2.38e+11. In the year 2013, what is the difference between the Taxes (in US$) in Cyprus and Taxes (in US$) in Singapore?
Offer a very short reply. -2.06e+1. In the year 2013, what is the difference between the Taxes (in US$) in Dominican Republic and Taxes (in US$) in Rwanda?
Your response must be concise. -6.74e+1. In the year 2013, what is the difference between the Taxes (in US$) of Dominican Republic and Taxes (in US$) of Singapore?
Make the answer very short. 1.50e+11. In the year 2013, what is the difference between the Taxes (in US$) in Rwanda and Taxes (in US$) in Singapore?
Keep it short and to the point. 2.17e+11. In the year 2014, what is the difference between the Taxes (in US$) of Cyprus and Taxes (in US$) of Dominican Republic?
Your answer should be very brief. -1.96e+11. In the year 2014, what is the difference between the Taxes (in US$) of Cyprus and Taxes (in US$) of Rwanda?
Offer a terse response. -2.91e+11. In the year 2014, what is the difference between the Taxes (in US$) in Cyprus and Taxes (in US$) in Singapore?
Your answer should be compact. -2.00e+1. In the year 2014, what is the difference between the Taxes (in US$) of Dominican Republic and Taxes (in US$) of Rwanda?
Offer a terse response. -9.58e+1. In the year 2014, what is the difference between the Taxes (in US$) of Dominican Republic and Taxes (in US$) of Singapore?
Your response must be concise. 1.76e+11. In the year 2014, what is the difference between the Taxes (in US$) in Rwanda and Taxes (in US$) in Singapore?
Ensure brevity in your answer.  2.71e+11. What is the ratio of the Taxes (in US$) of Cyprus in 2007 to that in 2008?
Offer a very short reply. 0.9. What is the ratio of the Taxes (in US$) in Rwanda in 2007 to that in 2008?
Ensure brevity in your answer.  0.73. What is the ratio of the Taxes (in US$) of Singapore in 2007 to that in 2008?
Make the answer very short. 1.09. What is the ratio of the Taxes (in US$) of Cyprus in 2007 to that in 2009?
Your response must be concise. 1.08. What is the ratio of the Taxes (in US$) of Dominican Republic in 2007 to that in 2009?
Offer a terse response. 0.97. What is the ratio of the Taxes (in US$) of Rwanda in 2007 to that in 2009?
Offer a very short reply. 0.66. What is the ratio of the Taxes (in US$) of Singapore in 2007 to that in 2009?
Provide a succinct answer. 1.11. What is the ratio of the Taxes (in US$) of Cyprus in 2007 to that in 2010?
Offer a very short reply. 1.06. What is the ratio of the Taxes (in US$) of Dominican Republic in 2007 to that in 2010?
Keep it short and to the point. 0.81. What is the ratio of the Taxes (in US$) of Rwanda in 2007 to that in 2010?
Provide a short and direct response. 0.59. What is the ratio of the Taxes (in US$) of Singapore in 2007 to that in 2010?
Your answer should be very brief. 0.86. What is the ratio of the Taxes (in US$) of Cyprus in 2007 to that in 2011?
Make the answer very short. 1.14. What is the ratio of the Taxes (in US$) in Dominican Republic in 2007 to that in 2011?
Offer a terse response. 0.77. What is the ratio of the Taxes (in US$) of Rwanda in 2007 to that in 2011?
Your answer should be very brief. 0.48. What is the ratio of the Taxes (in US$) in Singapore in 2007 to that in 2011?
Offer a terse response. 0.78. What is the ratio of the Taxes (in US$) of Cyprus in 2007 to that in 2012?
Offer a terse response. 1.12. What is the ratio of the Taxes (in US$) in Dominican Republic in 2007 to that in 2012?
Your response must be concise. 0.72. What is the ratio of the Taxes (in US$) of Rwanda in 2007 to that in 2012?
Your response must be concise. 0.52. What is the ratio of the Taxes (in US$) of Singapore in 2007 to that in 2012?
Ensure brevity in your answer.  0.74. What is the ratio of the Taxes (in US$) of Cyprus in 2007 to that in 2013?
Keep it short and to the point. 1.28. What is the ratio of the Taxes (in US$) of Dominican Republic in 2007 to that in 2013?
Offer a very short reply. 0.68. What is the ratio of the Taxes (in US$) in Rwanda in 2007 to that in 2013?
Offer a very short reply. 0.52. What is the ratio of the Taxes (in US$) in Singapore in 2007 to that in 2013?
Provide a succinct answer. 0.7. What is the ratio of the Taxes (in US$) in Cyprus in 2007 to that in 2014?
Provide a succinct answer. 1.2. What is the ratio of the Taxes (in US$) in Dominican Republic in 2007 to that in 2014?
Offer a terse response. 0.59. What is the ratio of the Taxes (in US$) in Rwanda in 2007 to that in 2014?
Offer a terse response. 0.42. What is the ratio of the Taxes (in US$) of Singapore in 2007 to that in 2014?
Offer a terse response. 0.72. What is the ratio of the Taxes (in US$) in Cyprus in 2008 to that in 2009?
Keep it short and to the point. 1.2. What is the ratio of the Taxes (in US$) in Dominican Republic in 2008 to that in 2009?
Offer a very short reply. 0.98. What is the ratio of the Taxes (in US$) in Rwanda in 2008 to that in 2009?
Provide a succinct answer. 0.9. What is the ratio of the Taxes (in US$) of Singapore in 2008 to that in 2009?
Your response must be concise. 1.02. What is the ratio of the Taxes (in US$) of Cyprus in 2008 to that in 2010?
Give a very brief answer. 1.19. What is the ratio of the Taxes (in US$) of Dominican Republic in 2008 to that in 2010?
Your answer should be compact. 0.81. What is the ratio of the Taxes (in US$) of Rwanda in 2008 to that in 2010?
Your response must be concise. 0.81. What is the ratio of the Taxes (in US$) in Singapore in 2008 to that in 2010?
Offer a terse response. 0.79. What is the ratio of the Taxes (in US$) in Cyprus in 2008 to that in 2011?
Give a very brief answer. 1.27. What is the ratio of the Taxes (in US$) of Dominican Republic in 2008 to that in 2011?
Ensure brevity in your answer.  0.78. What is the ratio of the Taxes (in US$) in Rwanda in 2008 to that in 2011?
Keep it short and to the point. 0.66. What is the ratio of the Taxes (in US$) in Singapore in 2008 to that in 2011?
Your answer should be compact. 0.72. What is the ratio of the Taxes (in US$) of Cyprus in 2008 to that in 2012?
Give a very brief answer. 1.25. What is the ratio of the Taxes (in US$) of Dominican Republic in 2008 to that in 2012?
Your answer should be compact. 0.73. What is the ratio of the Taxes (in US$) of Rwanda in 2008 to that in 2012?
Give a very brief answer. 0.71. What is the ratio of the Taxes (in US$) of Singapore in 2008 to that in 2012?
Your answer should be very brief. 0.68. What is the ratio of the Taxes (in US$) in Cyprus in 2008 to that in 2013?
Your response must be concise. 1.42. What is the ratio of the Taxes (in US$) in Dominican Republic in 2008 to that in 2013?
Your answer should be compact. 0.69. What is the ratio of the Taxes (in US$) in Rwanda in 2008 to that in 2013?
Provide a short and direct response. 0.71. What is the ratio of the Taxes (in US$) of Singapore in 2008 to that in 2013?
Offer a very short reply. 0.65. What is the ratio of the Taxes (in US$) of Cyprus in 2008 to that in 2014?
Offer a terse response. 1.34. What is the ratio of the Taxes (in US$) of Dominican Republic in 2008 to that in 2014?
Provide a succinct answer. 0.6. What is the ratio of the Taxes (in US$) in Rwanda in 2008 to that in 2014?
Keep it short and to the point. 0.58. What is the ratio of the Taxes (in US$) of Singapore in 2008 to that in 2014?
Offer a very short reply. 0.66. What is the ratio of the Taxes (in US$) of Cyprus in 2009 to that in 2010?
Offer a terse response. 0.99. What is the ratio of the Taxes (in US$) in Dominican Republic in 2009 to that in 2010?
Make the answer very short. 0.83. What is the ratio of the Taxes (in US$) in Rwanda in 2009 to that in 2010?
Your answer should be compact. 0.9. What is the ratio of the Taxes (in US$) of Singapore in 2009 to that in 2010?
Ensure brevity in your answer.  0.78. What is the ratio of the Taxes (in US$) in Cyprus in 2009 to that in 2011?
Offer a very short reply. 1.06. What is the ratio of the Taxes (in US$) of Dominican Republic in 2009 to that in 2011?
Ensure brevity in your answer.  0.79. What is the ratio of the Taxes (in US$) in Rwanda in 2009 to that in 2011?
Keep it short and to the point. 0.73. What is the ratio of the Taxes (in US$) of Singapore in 2009 to that in 2011?
Your answer should be very brief. 0.7. What is the ratio of the Taxes (in US$) of Cyprus in 2009 to that in 2012?
Your answer should be compact. 1.04. What is the ratio of the Taxes (in US$) in Dominican Republic in 2009 to that in 2012?
Ensure brevity in your answer.  0.74. What is the ratio of the Taxes (in US$) of Rwanda in 2009 to that in 2012?
Provide a short and direct response. 0.79. What is the ratio of the Taxes (in US$) in Singapore in 2009 to that in 2012?
Offer a very short reply. 0.66. What is the ratio of the Taxes (in US$) in Cyprus in 2009 to that in 2013?
Your answer should be compact. 1.19. What is the ratio of the Taxes (in US$) of Dominican Republic in 2009 to that in 2013?
Make the answer very short. 0.7. What is the ratio of the Taxes (in US$) in Rwanda in 2009 to that in 2013?
Keep it short and to the point. 0.79. What is the ratio of the Taxes (in US$) of Singapore in 2009 to that in 2013?
Provide a short and direct response. 0.63. What is the ratio of the Taxes (in US$) of Cyprus in 2009 to that in 2014?
Give a very brief answer. 1.11. What is the ratio of the Taxes (in US$) of Dominican Republic in 2009 to that in 2014?
Provide a short and direct response. 0.61. What is the ratio of the Taxes (in US$) of Rwanda in 2009 to that in 2014?
Ensure brevity in your answer.  0.64. What is the ratio of the Taxes (in US$) in Singapore in 2009 to that in 2014?
Your answer should be compact. 0.65. What is the ratio of the Taxes (in US$) of Cyprus in 2010 to that in 2011?
Make the answer very short. 1.07. What is the ratio of the Taxes (in US$) of Dominican Republic in 2010 to that in 2011?
Keep it short and to the point. 0.96. What is the ratio of the Taxes (in US$) in Rwanda in 2010 to that in 2011?
Offer a very short reply. 0.81. What is the ratio of the Taxes (in US$) of Singapore in 2010 to that in 2011?
Offer a terse response. 0.9. What is the ratio of the Taxes (in US$) of Cyprus in 2010 to that in 2012?
Keep it short and to the point. 1.05. What is the ratio of the Taxes (in US$) in Dominican Republic in 2010 to that in 2012?
Offer a very short reply. 0.9. What is the ratio of the Taxes (in US$) of Rwanda in 2010 to that in 2012?
Give a very brief answer. 0.88. What is the ratio of the Taxes (in US$) of Singapore in 2010 to that in 2012?
Offer a very short reply. 0.85. What is the ratio of the Taxes (in US$) in Cyprus in 2010 to that in 2013?
Make the answer very short. 1.2. What is the ratio of the Taxes (in US$) in Dominican Republic in 2010 to that in 2013?
Keep it short and to the point. 0.85. What is the ratio of the Taxes (in US$) of Rwanda in 2010 to that in 2013?
Make the answer very short. 0.87. What is the ratio of the Taxes (in US$) of Singapore in 2010 to that in 2013?
Keep it short and to the point. 0.81. What is the ratio of the Taxes (in US$) in Cyprus in 2010 to that in 2014?
Your answer should be very brief. 1.13. What is the ratio of the Taxes (in US$) in Dominican Republic in 2010 to that in 2014?
Provide a succinct answer. 0.74. What is the ratio of the Taxes (in US$) in Rwanda in 2010 to that in 2014?
Provide a short and direct response. 0.71. What is the ratio of the Taxes (in US$) in Singapore in 2010 to that in 2014?
Give a very brief answer. 0.83. What is the ratio of the Taxes (in US$) in Cyprus in 2011 to that in 2012?
Ensure brevity in your answer.  0.98. What is the ratio of the Taxes (in US$) in Dominican Republic in 2011 to that in 2012?
Provide a succinct answer. 0.94. What is the ratio of the Taxes (in US$) of Rwanda in 2011 to that in 2012?
Your answer should be compact. 1.09. What is the ratio of the Taxes (in US$) in Singapore in 2011 to that in 2012?
Offer a very short reply. 0.94. What is the ratio of the Taxes (in US$) in Cyprus in 2011 to that in 2013?
Ensure brevity in your answer.  1.12. What is the ratio of the Taxes (in US$) in Dominican Republic in 2011 to that in 2013?
Your response must be concise. 0.88. What is the ratio of the Taxes (in US$) of Rwanda in 2011 to that in 2013?
Offer a terse response. 1.08. What is the ratio of the Taxes (in US$) in Singapore in 2011 to that in 2013?
Provide a short and direct response. 0.9. What is the ratio of the Taxes (in US$) of Cyprus in 2011 to that in 2014?
Offer a terse response. 1.05. What is the ratio of the Taxes (in US$) in Dominican Republic in 2011 to that in 2014?
Give a very brief answer. 0.77. What is the ratio of the Taxes (in US$) of Rwanda in 2011 to that in 2014?
Offer a terse response. 0.88. What is the ratio of the Taxes (in US$) of Singapore in 2011 to that in 2014?
Make the answer very short. 0.92. What is the ratio of the Taxes (in US$) in Cyprus in 2012 to that in 2013?
Your answer should be very brief. 1.14. What is the ratio of the Taxes (in US$) of Dominican Republic in 2012 to that in 2013?
Your answer should be compact. 0.94. What is the ratio of the Taxes (in US$) in Singapore in 2012 to that in 2013?
Ensure brevity in your answer.  0.95. What is the ratio of the Taxes (in US$) in Cyprus in 2012 to that in 2014?
Offer a very short reply. 1.07. What is the ratio of the Taxes (in US$) of Dominican Republic in 2012 to that in 2014?
Your response must be concise. 0.82. What is the ratio of the Taxes (in US$) in Rwanda in 2012 to that in 2014?
Your response must be concise. 0.81. What is the ratio of the Taxes (in US$) of Singapore in 2012 to that in 2014?
Keep it short and to the point. 0.98. What is the ratio of the Taxes (in US$) in Cyprus in 2013 to that in 2014?
Provide a short and direct response. 0.94. What is the ratio of the Taxes (in US$) of Dominican Republic in 2013 to that in 2014?
Keep it short and to the point. 0.87. What is the ratio of the Taxes (in US$) in Rwanda in 2013 to that in 2014?
Offer a terse response. 0.82. What is the ratio of the Taxes (in US$) in Singapore in 2013 to that in 2014?
Provide a succinct answer. 1.02. What is the difference between the highest and the second highest Taxes (in US$) in Cyprus?
Ensure brevity in your answer.  2.14e+08. What is the difference between the highest and the second highest Taxes (in US$) in Dominican Republic?
Provide a short and direct response. 2.56e+1. What is the difference between the highest and the second highest Taxes (in US$) of Rwanda?
Keep it short and to the point. 3.50e+1. What is the difference between the highest and the second highest Taxes (in US$) in Singapore?
Provide a succinct answer. 4.90e+08. What is the difference between the highest and the lowest Taxes (in US$) in Cyprus?
Offer a terse response. 6.08e+08. What is the difference between the highest and the lowest Taxes (in US$) in Dominican Republic?
Offer a very short reply. 8.01e+1. What is the difference between the highest and the lowest Taxes (in US$) in Rwanda?
Provide a succinct answer. 1.69e+11. What is the difference between the highest and the lowest Taxes (in US$) of Singapore?
Your answer should be very brief. 8.12e+09. 